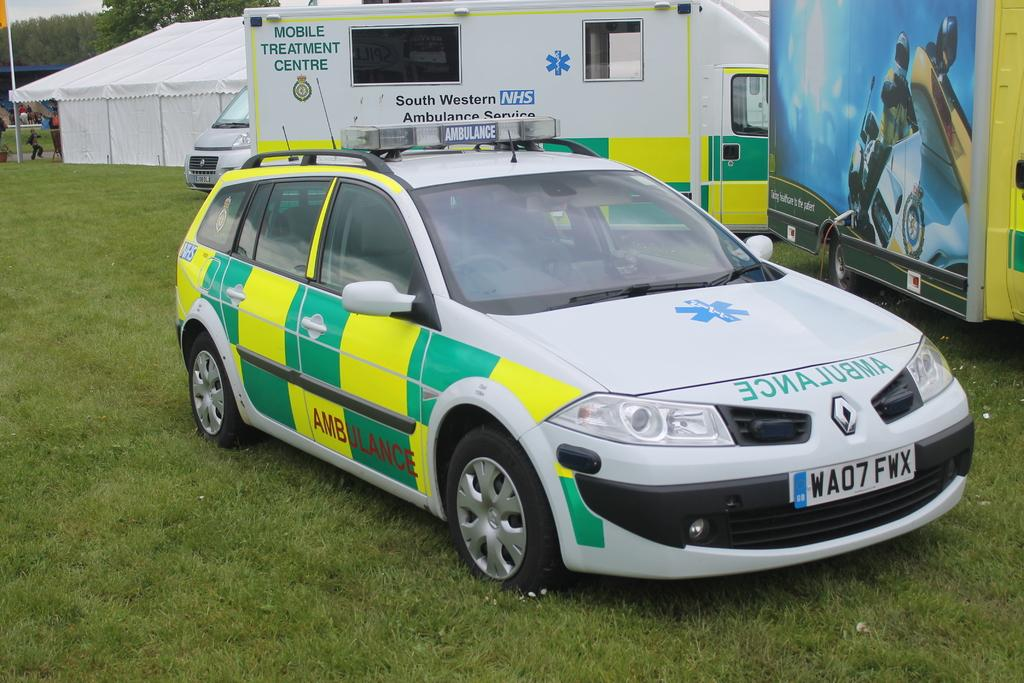What is located in the foreground of the image? There is a car on the grass in the foreground of the image. What can be seen in the background of the image? There are vehicles, a white tent, a flag, people, trees, and the sky visible in the background of the image. What type of rail can be seen in the image? There is no rail present in the image. How many times does the car fall over in the image? The car does not fall over in the image; it is stationary on the grass. 